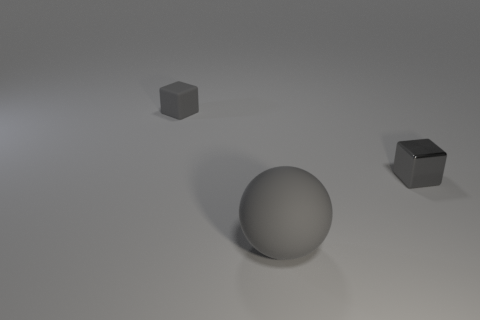The cube that is made of the same material as the sphere is what color?
Your answer should be very brief. Gray. How many rubber objects are small objects or large balls?
Your answer should be very brief. 2. There is a small gray object that is in front of the gray rubber cube; what is its shape?
Ensure brevity in your answer.  Cube. Is there a tiny metallic block that is to the left of the small gray block that is on the left side of the tiny metal block?
Offer a terse response. No. Are there any green matte cubes of the same size as the ball?
Provide a short and direct response. No. There is a block that is to the right of the large matte sphere; is it the same color as the big thing?
Provide a short and direct response. Yes. What size is the gray sphere?
Make the answer very short. Large. There is a gray matte sphere in front of the object that is behind the gray metallic block; what is its size?
Your answer should be very brief. Large. How many matte balls are the same color as the small matte object?
Your answer should be compact. 1. How many spheres are there?
Your response must be concise. 1. 